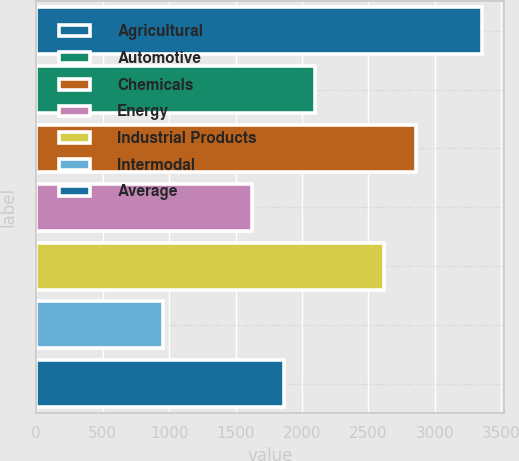Convert chart to OTSL. <chart><loc_0><loc_0><loc_500><loc_500><bar_chart><fcel>Agricultural<fcel>Automotive<fcel>Chemicals<fcel>Energy<fcel>Industrial Products<fcel>Intermodal<fcel>Average<nl><fcel>3352<fcel>2101.4<fcel>2859.7<fcel>1622<fcel>2620<fcel>955<fcel>1861.7<nl></chart> 